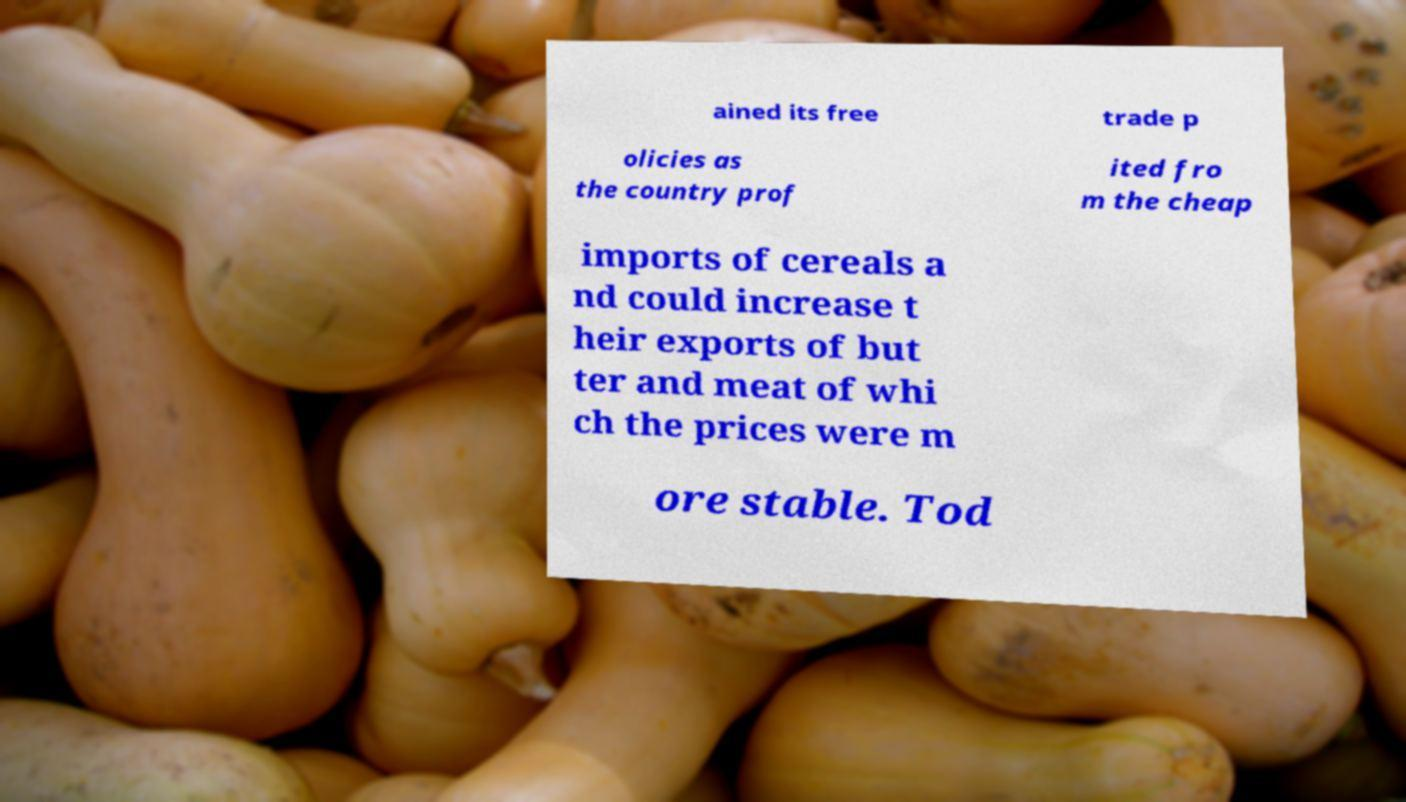Please read and relay the text visible in this image. What does it say? ained its free trade p olicies as the country prof ited fro m the cheap imports of cereals a nd could increase t heir exports of but ter and meat of whi ch the prices were m ore stable. Tod 